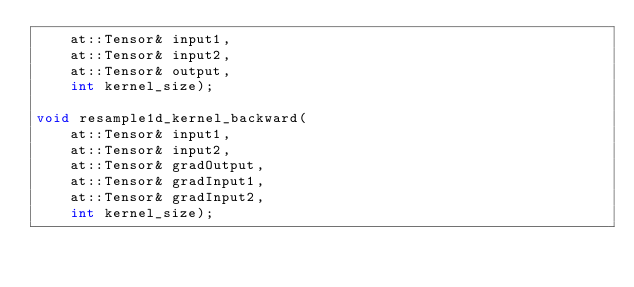<code> <loc_0><loc_0><loc_500><loc_500><_Cuda_>    at::Tensor& input1,
    at::Tensor& input2,
    at::Tensor& output,
    int kernel_size);

void resample1d_kernel_backward(
    at::Tensor& input1,
    at::Tensor& input2,
    at::Tensor& gradOutput,
    at::Tensor& gradInput1,
    at::Tensor& gradInput2,
    int kernel_size);</code> 